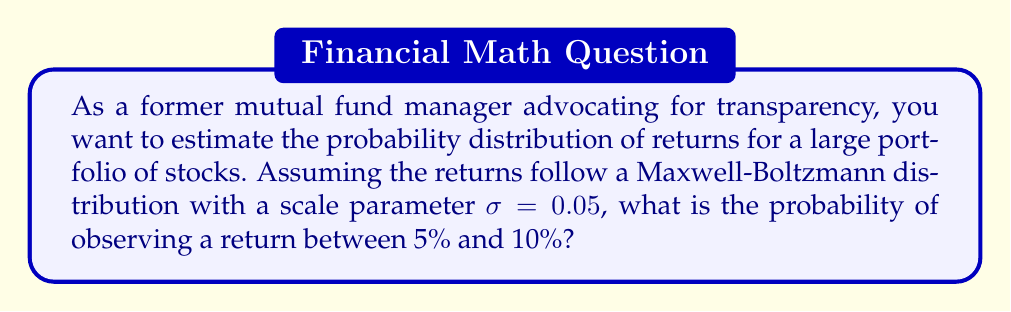Help me with this question. To solve this problem, we'll follow these steps:

1) The Maxwell-Boltzmann distribution probability density function is given by:

   $$f(x) = \sqrt{\frac{2}{\pi}} \frac{x^2}{\sigma^3} e^{-x^2/(2\sigma^2)}$$

2) To find the probability of a return between 5% and 10%, we need to integrate this function from 0.05 to 0.10:

   $$P(0.05 \leq x \leq 0.10) = \int_{0.05}^{0.10} f(x) dx$$

3) Substituting the given $\sigma = 0.05$:

   $$P(0.05 \leq x \leq 0.10) = \int_{0.05}^{0.10} \sqrt{\frac{2}{\pi}} \frac{x^2}{0.05^3} e^{-x^2/(2(0.05)^2)} dx$$

4) This integral doesn't have a simple analytical solution, so we need to use numerical integration. Using a computational tool, we can evaluate this integral.

5) The result of this numerical integration is approximately 0.1859.

6) To interpret this result: there is about an 18.59% chance of observing a return between 5% and 10% in this portfolio, assuming the returns follow a Maxwell-Boltzmann distribution with the given parameter.

This analysis provides a quantitative measure of return probabilities, contributing to the transparency you advocate for in investment management.
Answer: 0.1859 or 18.59% 